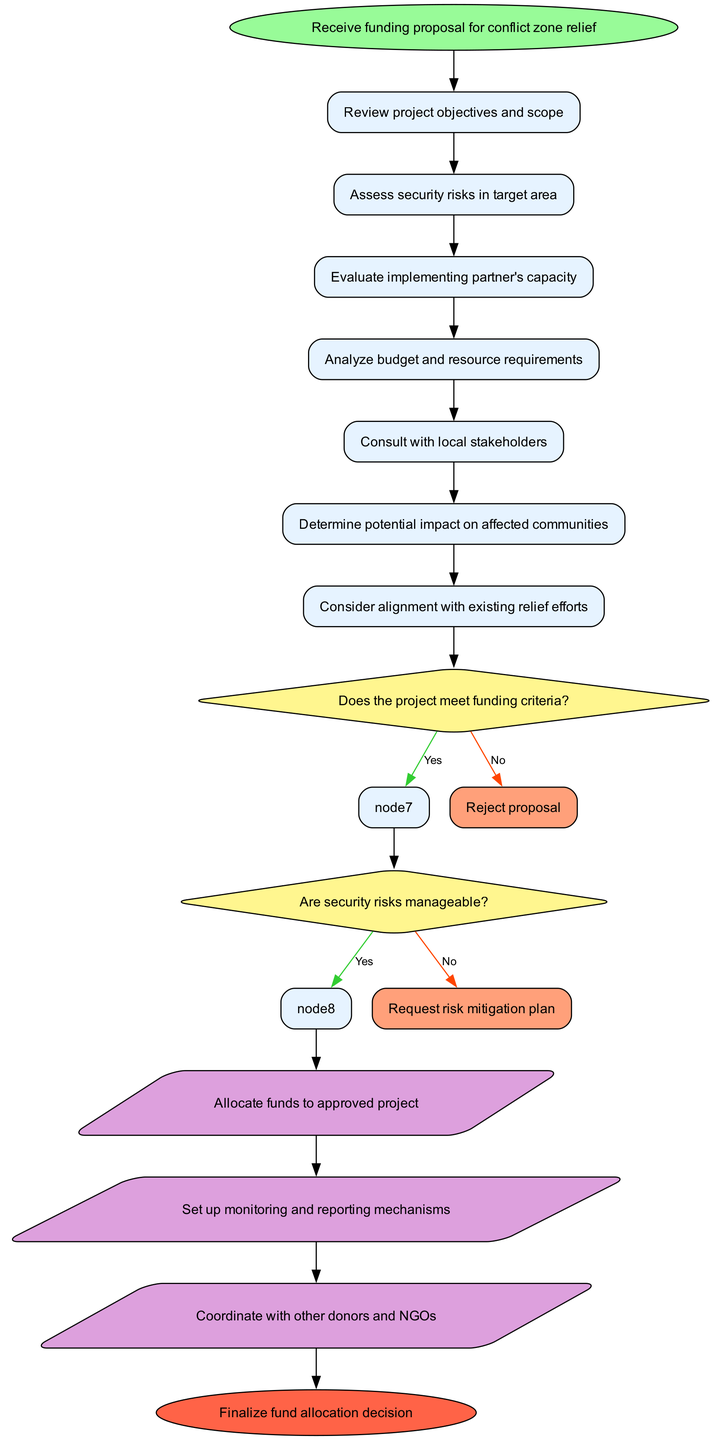What is the starting point of the flow chart? The starting point is clearly indicated in the diagram as the first node, labeled "Receive funding proposal for conflict zone relief."
Answer: Receive funding proposal for conflict zone relief How many nodes are included in this diagram? By counting all the unique nodes within the flow chart, it includes a total of 8 nodes: "Receive funding proposal for conflict zone relief," the 6 process nodes, and the end node.
Answer: 8 What is the first decision in the workflow? Looking at the flow chart, the very first decision made after assessing the project objectives is whether the project meets the funding criteria.
Answer: Does the project meet funding criteria? What happens if security risks are not manageable? The flow chart indicates that if security risks are not manageable, the next step is to request a risk mitigation plan.
Answer: Request risk mitigation plan If the project proposal is rejected, what is the next step? According to the diagram, if the project proposal does not meet the funding criteria and is rejected, there are no further actions indicated, which leads directly out of the flow.
Answer: Reject proposal What is the final action in the allocation process? The flow chart shows that the final action taken in the fund allocation decision-making process is to finalize the fund allocation decision.
Answer: Finalize fund allocation decision How many actions are proposed after completing the evaluations and decisions? Upon examining the actions listed after the evaluations and decisions, there are 3 proposed actions in total, which include allocating funds, setting up monitoring, and coordinating with other donors.
Answer: 3 What node follows the action of allocating funds to the approved project? The next node after allocating funds to the approved project is to set up monitoring and reporting mechanisms according to the flow chart.
Answer: Set up monitoring and reporting mechanisms 